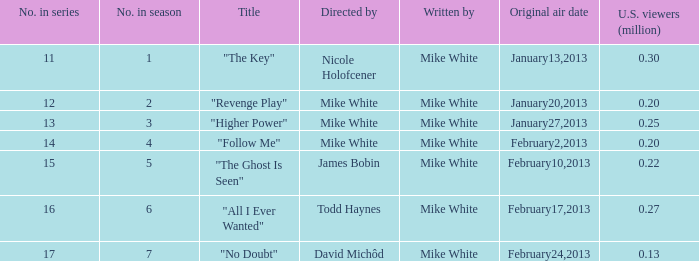Who directed the episode that have 0.25 million u.s viewers Mike White. 